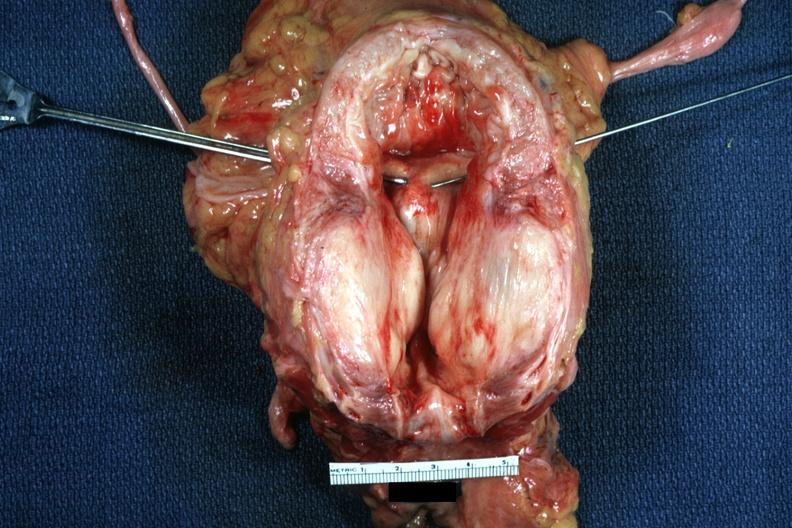what is present?
Answer the question using a single word or phrase. Hyperplasia 